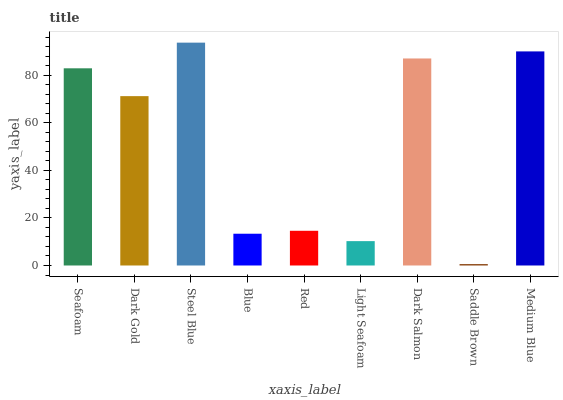Is Saddle Brown the minimum?
Answer yes or no. Yes. Is Steel Blue the maximum?
Answer yes or no. Yes. Is Dark Gold the minimum?
Answer yes or no. No. Is Dark Gold the maximum?
Answer yes or no. No. Is Seafoam greater than Dark Gold?
Answer yes or no. Yes. Is Dark Gold less than Seafoam?
Answer yes or no. Yes. Is Dark Gold greater than Seafoam?
Answer yes or no. No. Is Seafoam less than Dark Gold?
Answer yes or no. No. Is Dark Gold the high median?
Answer yes or no. Yes. Is Dark Gold the low median?
Answer yes or no. Yes. Is Medium Blue the high median?
Answer yes or no. No. Is Red the low median?
Answer yes or no. No. 